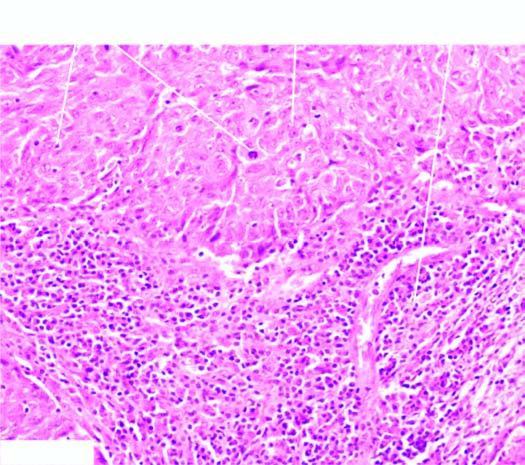does microscopy show two characteristic features-large tumour cells forming syncytial arrangement and stroma infiltrated richly with lymphocytes?
Answer the question using a single word or phrase. Yes 